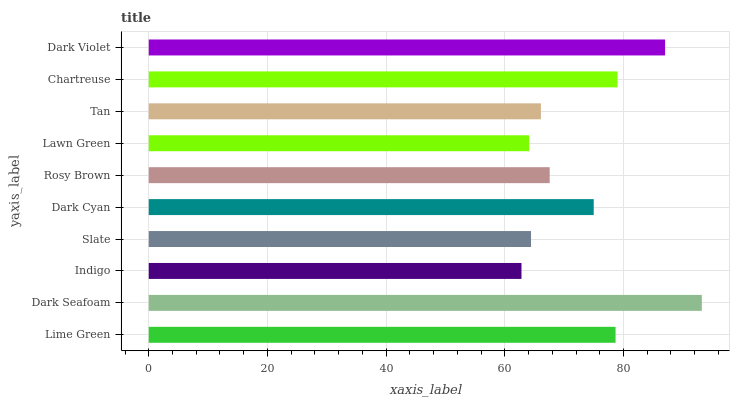Is Indigo the minimum?
Answer yes or no. Yes. Is Dark Seafoam the maximum?
Answer yes or no. Yes. Is Dark Seafoam the minimum?
Answer yes or no. No. Is Indigo the maximum?
Answer yes or no. No. Is Dark Seafoam greater than Indigo?
Answer yes or no. Yes. Is Indigo less than Dark Seafoam?
Answer yes or no. Yes. Is Indigo greater than Dark Seafoam?
Answer yes or no. No. Is Dark Seafoam less than Indigo?
Answer yes or no. No. Is Dark Cyan the high median?
Answer yes or no. Yes. Is Rosy Brown the low median?
Answer yes or no. Yes. Is Lawn Green the high median?
Answer yes or no. No. Is Dark Seafoam the low median?
Answer yes or no. No. 